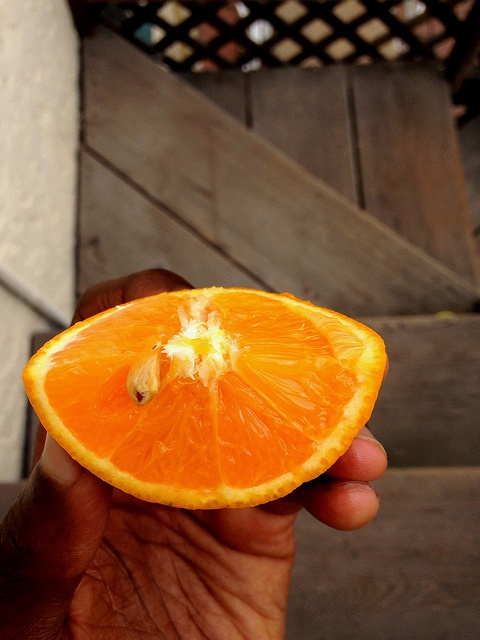Describe the objects in this image and their specific colors. I can see orange in tan, orange, red, and gold tones and people in tan, maroon, black, and brown tones in this image. 